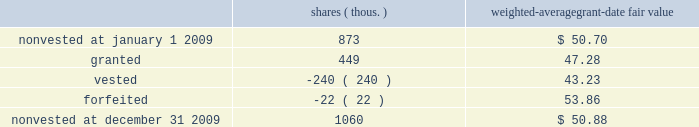Changes in our performance retention awards during 2009 were as follows : shares ( thous. ) weighted-average grant-date fair value .
At december 31 , 2009 , there was $ 22 million of total unrecognized compensation expense related to nonvested performance retention awards , which is expected to be recognized over a weighted-average period of 1.3 years .
A portion of this expense is subject to achievement of the roic levels established for the performance stock unit grants .
Retirement plans pension and other postretirement benefits pension plans 2013 we provide defined benefit retirement income to eligible non-union employees through qualified and non-qualified ( supplemental ) pension plans .
Qualified and non-qualified pension benefits are based on years of service and the highest compensation during the latest years of employment , with specific reductions made for early retirements .
Other postretirement benefits ( opeb ) 2013 we provide defined contribution medical and life insurance benefits for eligible retirees .
These benefits are funded as medical claims and life insurance premiums are plan amendment effective january 1 , 2010 , medicare-eligible retirees who are enrolled in the union pacific retiree medical program will receive a contribution to a health reimbursement account , which can be used to pay eligible out-of-pocket medical expenses .
The impact of the plan amendment is reflected in the projected benefit obligation ( pbo ) at december 31 , 2009 .
Funded status we are required by gaap to separately recognize the overfunded or underfunded status of our pension and opeb plans as an asset or liability .
The funded status represents the difference between the pbo and the fair value of the plan assets .
The pbo is the present value of benefits earned to date by plan participants , including the effect of assumed future salary increases .
The pbo of the opeb plan is equal to the accumulated benefit obligation , as the present value of the opeb liabilities is not affected by salary increases .
Plan assets are measured at fair value .
We use a december 31 measurement date for plan assets and obligations for all our retirement plans. .
What is the annual compensation expense for the remaining unvested performance retention awards? 
Computations: ((22 * 1000000) / 1.3)
Answer: 16923076.92308. 